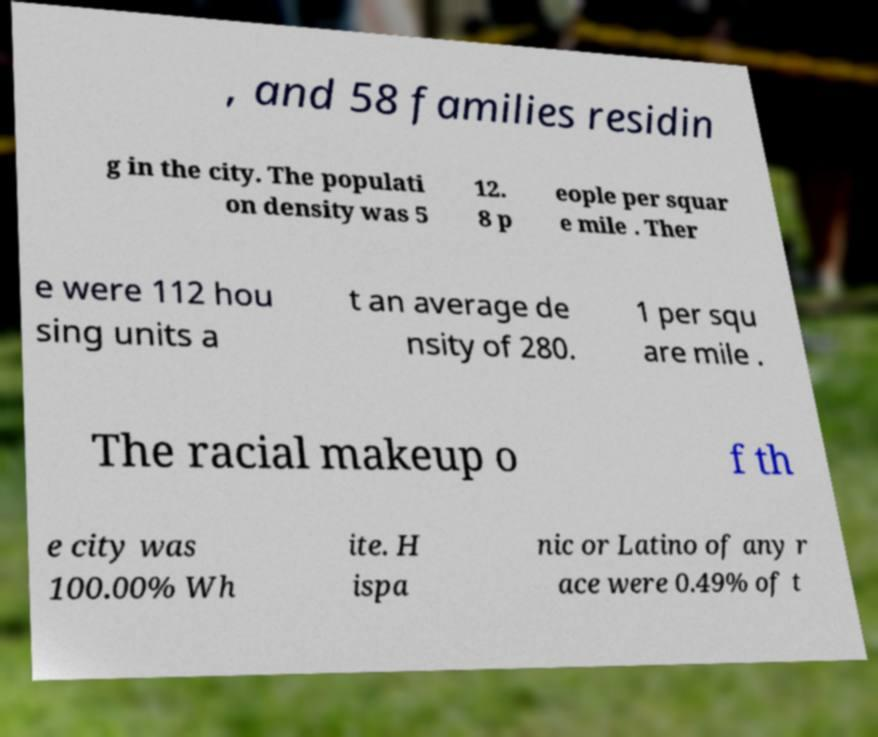I need the written content from this picture converted into text. Can you do that? , and 58 families residin g in the city. The populati on density was 5 12. 8 p eople per squar e mile . Ther e were 112 hou sing units a t an average de nsity of 280. 1 per squ are mile . The racial makeup o f th e city was 100.00% Wh ite. H ispa nic or Latino of any r ace were 0.49% of t 